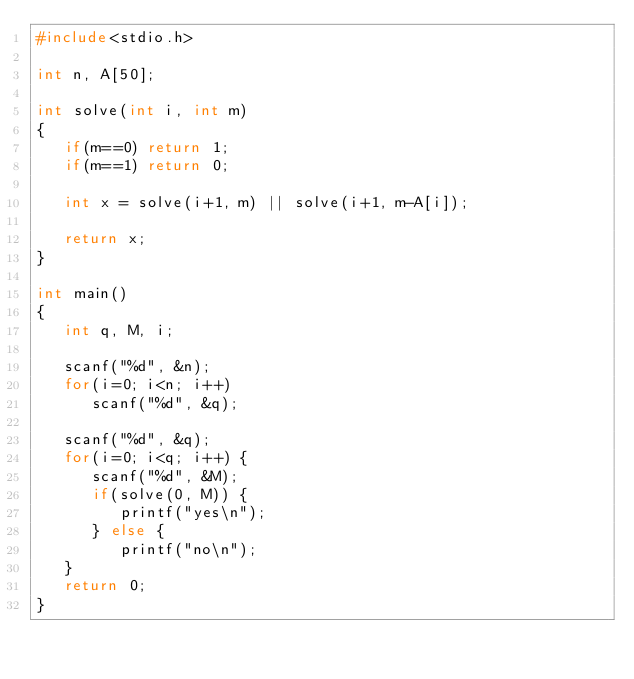Convert code to text. <code><loc_0><loc_0><loc_500><loc_500><_C_>#include<stdio.h>

int n, A[50];

int solve(int i, int m)
{
   if(m==0) return 1;
   if(m==1) return 0;

   int x = solve(i+1, m) || solve(i+1, m-A[i]);

   return x;
}

int main()
{
   int q, M, i;

   scanf("%d", &n);
   for(i=0; i<n; i++)
      scanf("%d", &q);

   scanf("%d", &q);
   for(i=0; i<q; i++) {
      scanf("%d", &M);
      if(solve(0, M)) {
         printf("yes\n");
      } else {
         printf("no\n");
   }
   return 0;
}</code> 